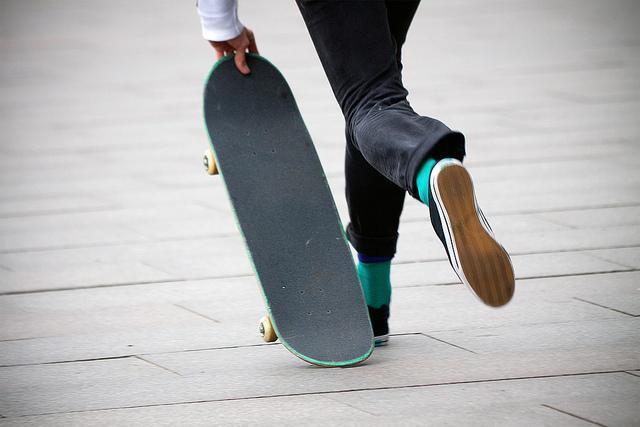How many wheels are shown?
Give a very brief answer. 2. 